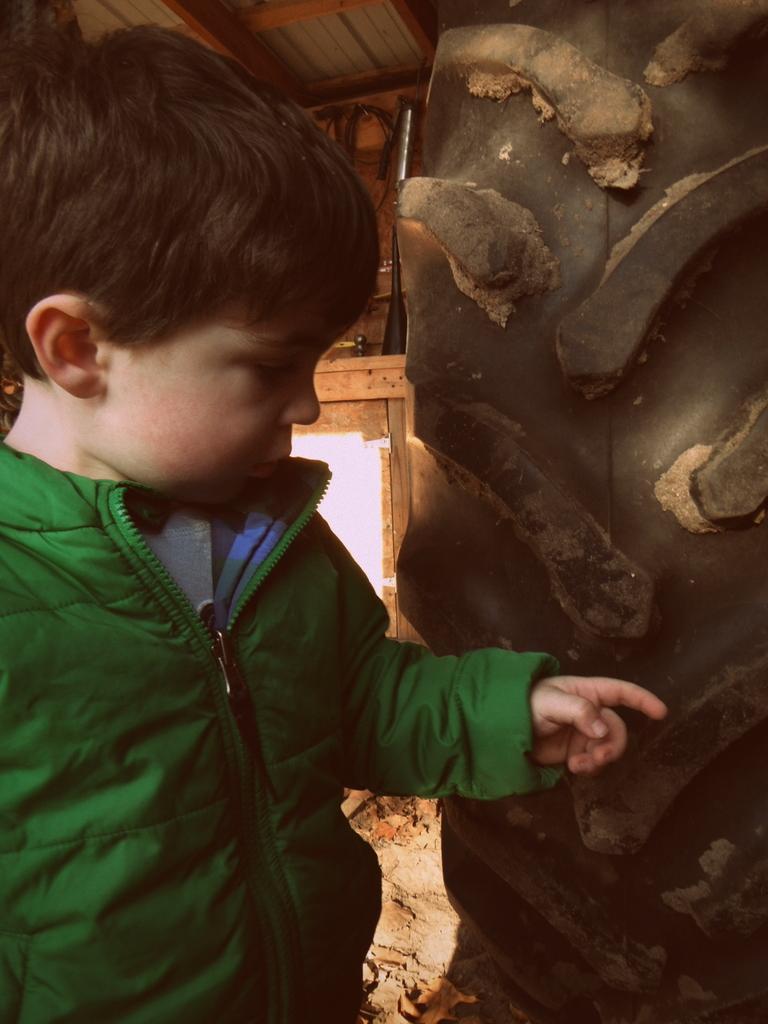Please provide a concise description of this image. In this picture I can see a boy in front and I see that he is wearing green color jacket and I can see the wall on the right side of this picture. 